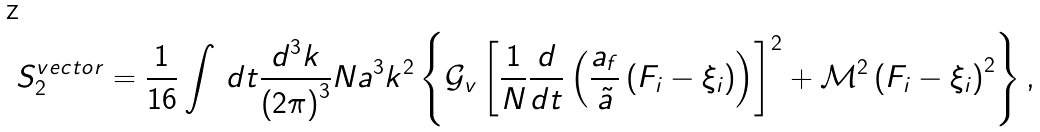Convert formula to latex. <formula><loc_0><loc_0><loc_500><loc_500>S _ { 2 } ^ { v e c t o r } = \frac { 1 } { 1 6 } \int \, d t \frac { d ^ { 3 } k } { \left ( 2 \pi \right ) ^ { 3 } } N a ^ { 3 } k ^ { 2 } \left \{ \mathcal { G } _ { v } \left [ \frac { 1 } { N } \frac { d } { d t } \left ( \frac { a _ { f } } { \tilde { a } } \left ( F _ { i } - \xi _ { i } \right ) \right ) \right ] ^ { 2 } + \mathcal { M } ^ { 2 } \left ( F _ { i } - \xi _ { i } \right ) ^ { 2 } \right \} ,</formula> 